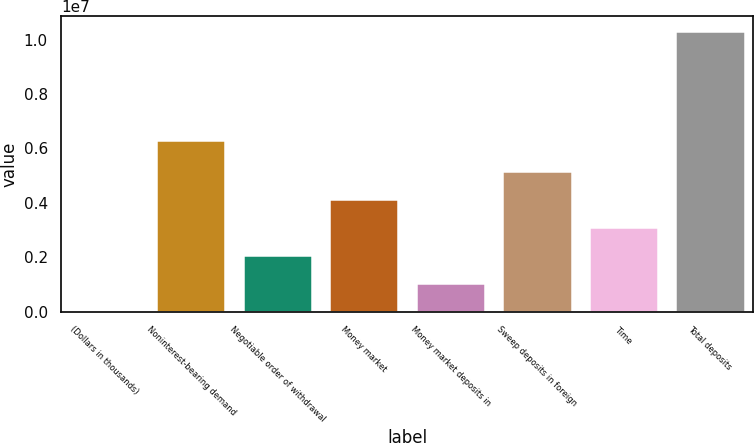<chart> <loc_0><loc_0><loc_500><loc_500><bar_chart><fcel>(Dollars in thousands)<fcel>Noninterest-bearing demand<fcel>Negotiable order of withdrawal<fcel>Money market<fcel>Money market deposits in<fcel>Sweep deposits in foreign<fcel>Time<fcel>Total deposits<nl><fcel>2009<fcel>6.29899e+06<fcel>2.06799e+06<fcel>4.13398e+06<fcel>1.035e+06<fcel>5.16697e+06<fcel>3.10099e+06<fcel>1.03319e+07<nl></chart> 